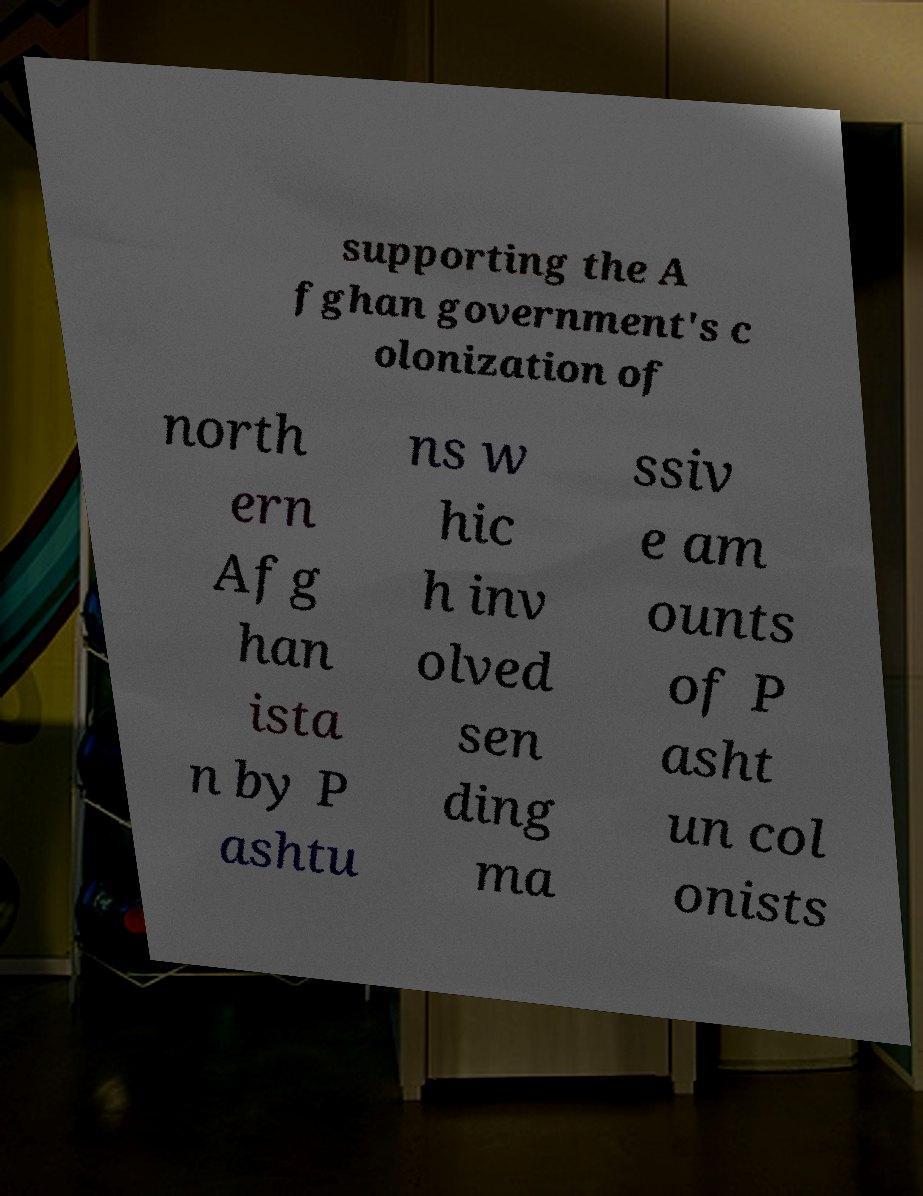Can you read and provide the text displayed in the image?This photo seems to have some interesting text. Can you extract and type it out for me? supporting the A fghan government's c olonization of north ern Afg han ista n by P ashtu ns w hic h inv olved sen ding ma ssiv e am ounts of P asht un col onists 